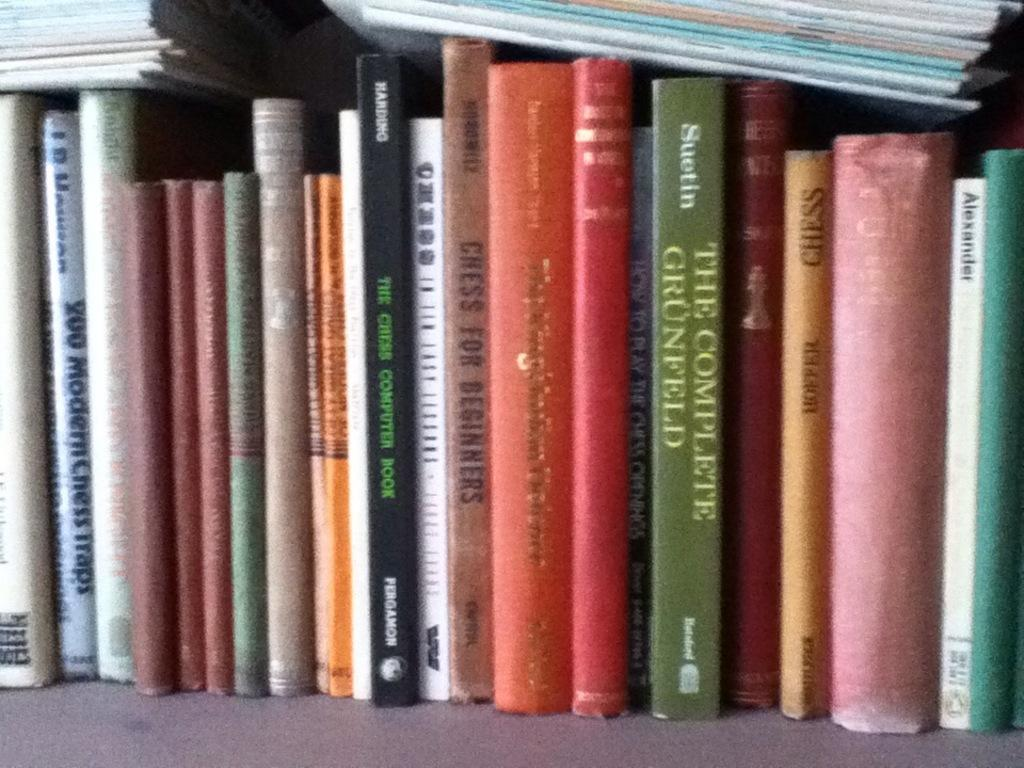<image>
Summarize the visual content of the image. A row of books on a shelf and one of them says The Complete Grunfeld. 